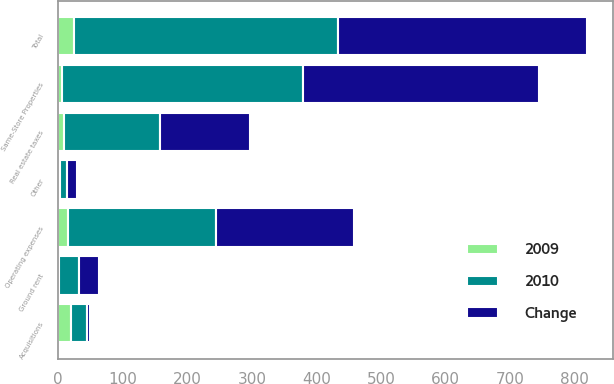Convert chart. <chart><loc_0><loc_0><loc_500><loc_500><stacked_bar_chart><ecel><fcel>Operating expenses<fcel>Real estate taxes<fcel>Ground rent<fcel>Total<fcel>Same-Store Properties<fcel>Acquisitions<fcel>Other<nl><fcel>2010<fcel>229.3<fcel>148.8<fcel>31.2<fcel>409.3<fcel>372.6<fcel>24.6<fcel>12.1<nl><fcel>Change<fcel>214<fcel>139.5<fcel>31.8<fcel>385.3<fcel>366.8<fcel>4.2<fcel>14.3<nl><fcel>2009<fcel>15.3<fcel>9.3<fcel>0.6<fcel>24<fcel>5.8<fcel>20.4<fcel>2.2<nl></chart> 